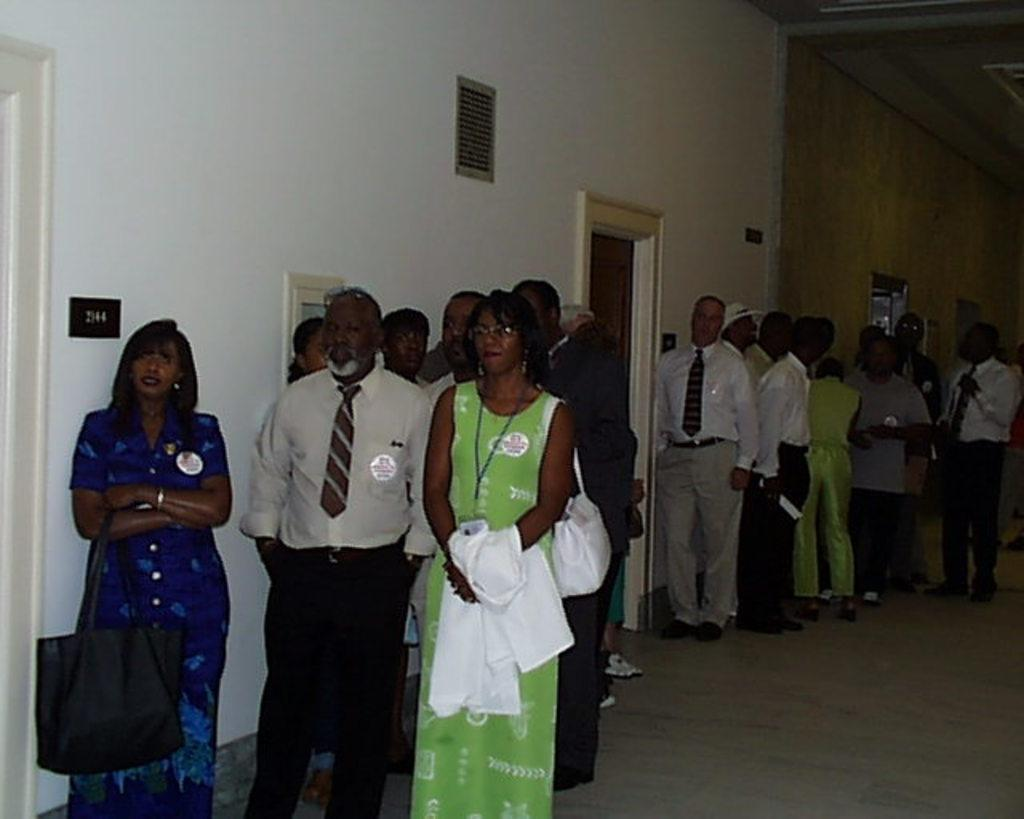How many people are present in the image? There are many people in the image. Where are the people located? The people are standing outside. What can be seen on the wall beside the doors? Door numbers are attached to the wall beside the doors. What type of lumber is being used to build the cemetery in the image? There is no cemetery or lumber present in the image. 